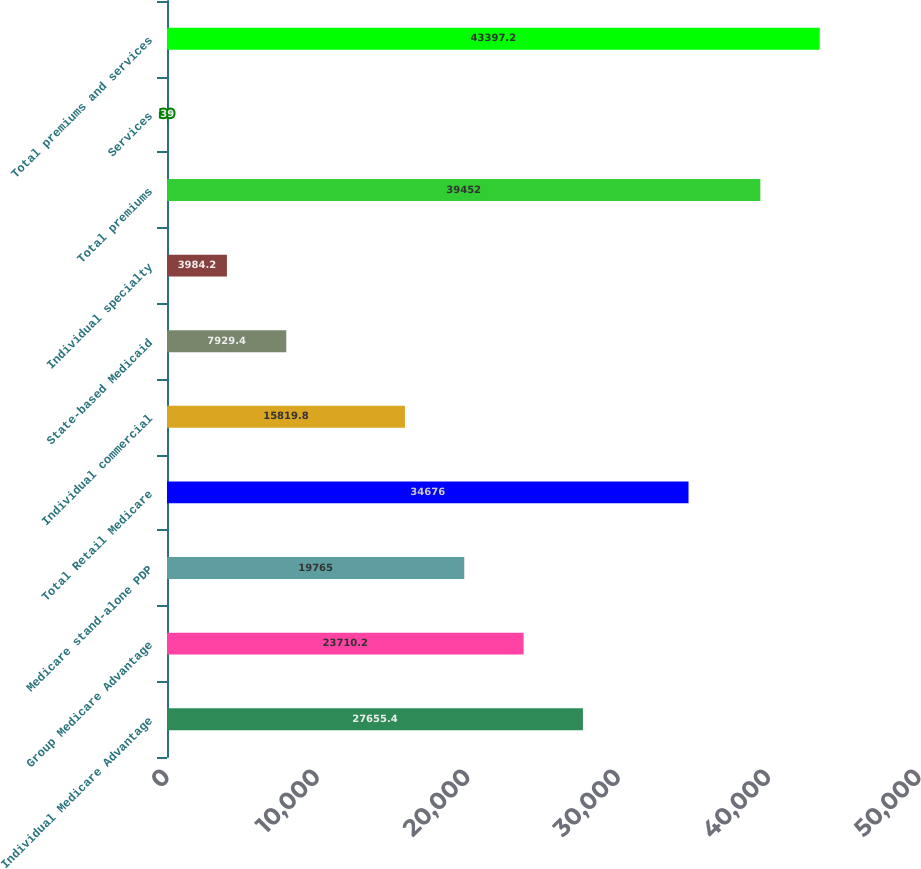<chart> <loc_0><loc_0><loc_500><loc_500><bar_chart><fcel>Individual Medicare Advantage<fcel>Group Medicare Advantage<fcel>Medicare stand-alone PDP<fcel>Total Retail Medicare<fcel>Individual commercial<fcel>State-based Medicaid<fcel>Individual specialty<fcel>Total premiums<fcel>Services<fcel>Total premiums and services<nl><fcel>27655.4<fcel>23710.2<fcel>19765<fcel>34676<fcel>15819.8<fcel>7929.4<fcel>3984.2<fcel>39452<fcel>39<fcel>43397.2<nl></chart> 